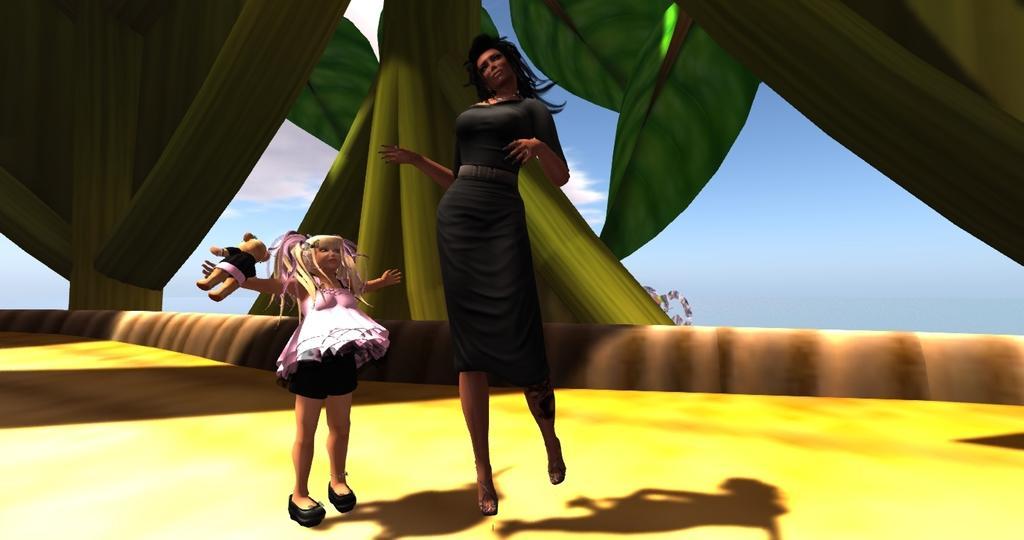How would you summarize this image in a sentence or two? This picture describes about animation, in the animation we can find a woman, a girl and a toy. 